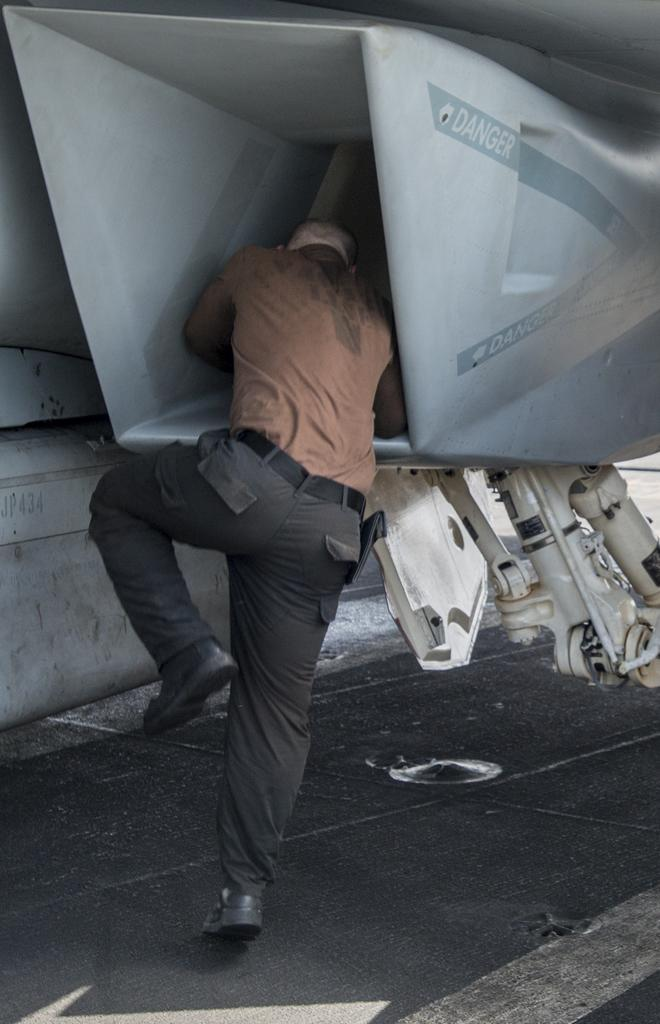Who or what can be seen in the image? There is a person in the image. What is the person wearing? The person is wearing a brown and black colored dress. Where is the person standing? The person is standing on the ground. What is the large grey object in the image? There is a huge grey colored object in the image. What is the person's opinion on the argument between the two animals in the image? There are no animals or argument present in the image, so it is not possible to determine the person's opinion on the matter. 